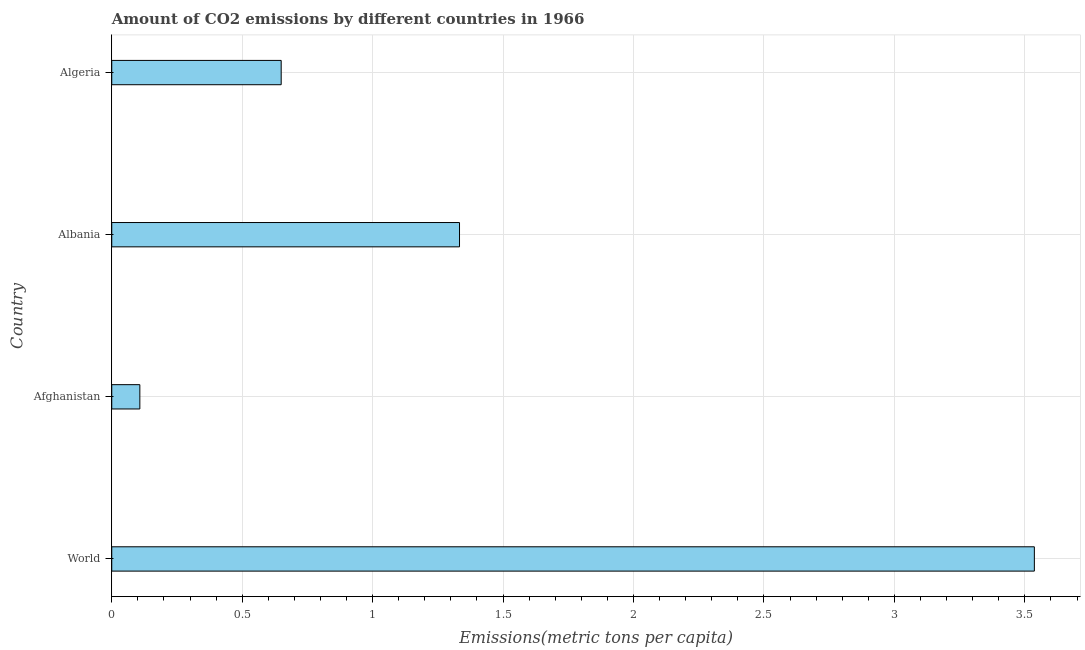Does the graph contain any zero values?
Your answer should be compact. No. Does the graph contain grids?
Your answer should be compact. Yes. What is the title of the graph?
Your response must be concise. Amount of CO2 emissions by different countries in 1966. What is the label or title of the X-axis?
Your answer should be very brief. Emissions(metric tons per capita). What is the label or title of the Y-axis?
Keep it short and to the point. Country. What is the amount of co2 emissions in Algeria?
Ensure brevity in your answer.  0.65. Across all countries, what is the maximum amount of co2 emissions?
Keep it short and to the point. 3.54. Across all countries, what is the minimum amount of co2 emissions?
Your answer should be compact. 0.11. In which country was the amount of co2 emissions minimum?
Offer a very short reply. Afghanistan. What is the sum of the amount of co2 emissions?
Your answer should be compact. 5.63. What is the difference between the amount of co2 emissions in Albania and Algeria?
Ensure brevity in your answer.  0.68. What is the average amount of co2 emissions per country?
Offer a very short reply. 1.41. What is the median amount of co2 emissions?
Your response must be concise. 0.99. In how many countries, is the amount of co2 emissions greater than 2.3 metric tons per capita?
Offer a very short reply. 1. What is the ratio of the amount of co2 emissions in Afghanistan to that in World?
Provide a short and direct response. 0.03. What is the difference between the highest and the second highest amount of co2 emissions?
Give a very brief answer. 2.2. What is the difference between the highest and the lowest amount of co2 emissions?
Provide a short and direct response. 3.43. How many bars are there?
Your response must be concise. 4. How many countries are there in the graph?
Give a very brief answer. 4. What is the difference between two consecutive major ticks on the X-axis?
Your answer should be compact. 0.5. Are the values on the major ticks of X-axis written in scientific E-notation?
Offer a terse response. No. What is the Emissions(metric tons per capita) of World?
Give a very brief answer. 3.54. What is the Emissions(metric tons per capita) of Afghanistan?
Make the answer very short. 0.11. What is the Emissions(metric tons per capita) of Albania?
Provide a short and direct response. 1.33. What is the Emissions(metric tons per capita) of Algeria?
Your response must be concise. 0.65. What is the difference between the Emissions(metric tons per capita) in World and Afghanistan?
Your answer should be very brief. 3.43. What is the difference between the Emissions(metric tons per capita) in World and Albania?
Offer a terse response. 2.2. What is the difference between the Emissions(metric tons per capita) in World and Algeria?
Your response must be concise. 2.89. What is the difference between the Emissions(metric tons per capita) in Afghanistan and Albania?
Give a very brief answer. -1.23. What is the difference between the Emissions(metric tons per capita) in Afghanistan and Algeria?
Your answer should be very brief. -0.54. What is the difference between the Emissions(metric tons per capita) in Albania and Algeria?
Keep it short and to the point. 0.68. What is the ratio of the Emissions(metric tons per capita) in World to that in Afghanistan?
Your answer should be compact. 32.84. What is the ratio of the Emissions(metric tons per capita) in World to that in Albania?
Offer a terse response. 2.65. What is the ratio of the Emissions(metric tons per capita) in World to that in Algeria?
Provide a short and direct response. 5.45. What is the ratio of the Emissions(metric tons per capita) in Afghanistan to that in Albania?
Keep it short and to the point. 0.08. What is the ratio of the Emissions(metric tons per capita) in Afghanistan to that in Algeria?
Your answer should be compact. 0.17. What is the ratio of the Emissions(metric tons per capita) in Albania to that in Algeria?
Offer a very short reply. 2.05. 